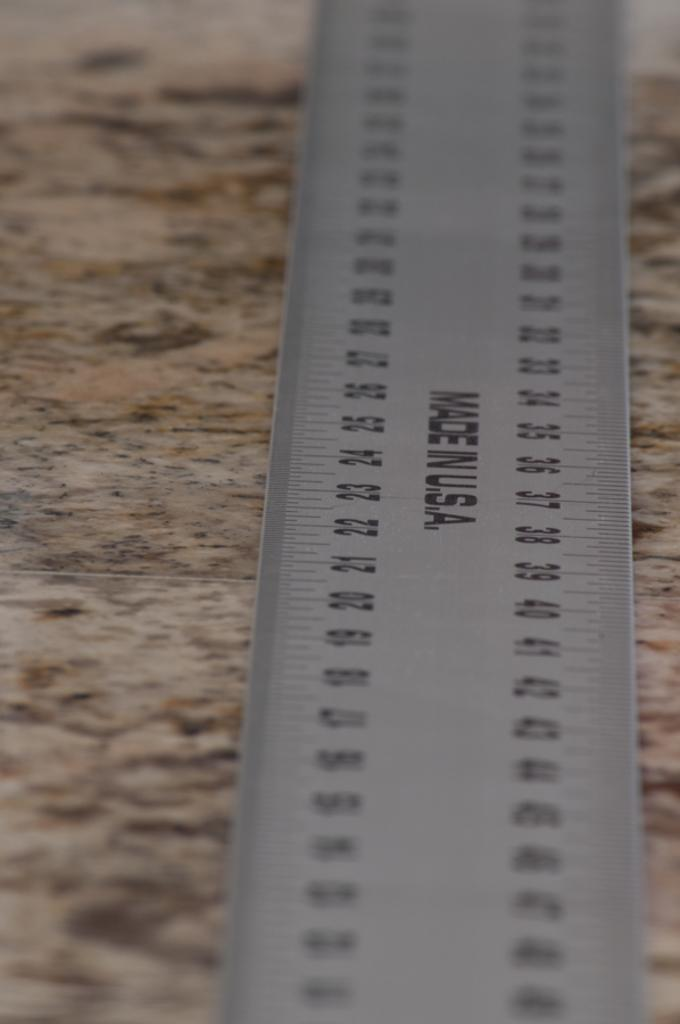<image>
Write a terse but informative summary of the picture. A metal ruler laying a marble surface that is made in the USA. 